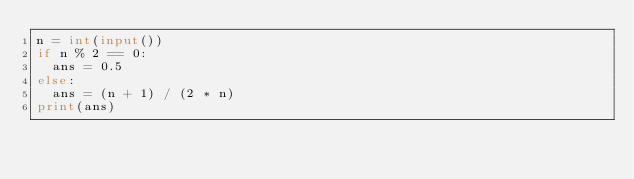Convert code to text. <code><loc_0><loc_0><loc_500><loc_500><_Python_>n = int(input())
if n % 2 == 0:
  ans = 0.5
else:
  ans = (n + 1) / (2 * n)
print(ans)</code> 